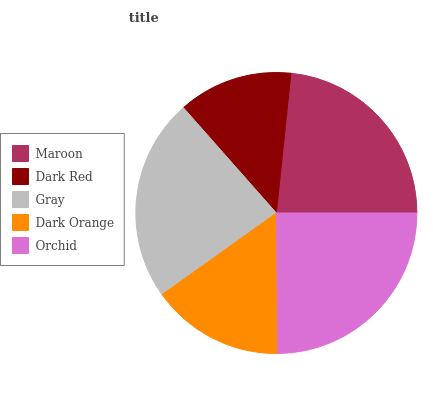Is Dark Red the minimum?
Answer yes or no. Yes. Is Orchid the maximum?
Answer yes or no. Yes. Is Gray the minimum?
Answer yes or no. No. Is Gray the maximum?
Answer yes or no. No. Is Gray greater than Dark Red?
Answer yes or no. Yes. Is Dark Red less than Gray?
Answer yes or no. Yes. Is Dark Red greater than Gray?
Answer yes or no. No. Is Gray less than Dark Red?
Answer yes or no. No. Is Maroon the high median?
Answer yes or no. Yes. Is Maroon the low median?
Answer yes or no. Yes. Is Gray the high median?
Answer yes or no. No. Is Dark Red the low median?
Answer yes or no. No. 